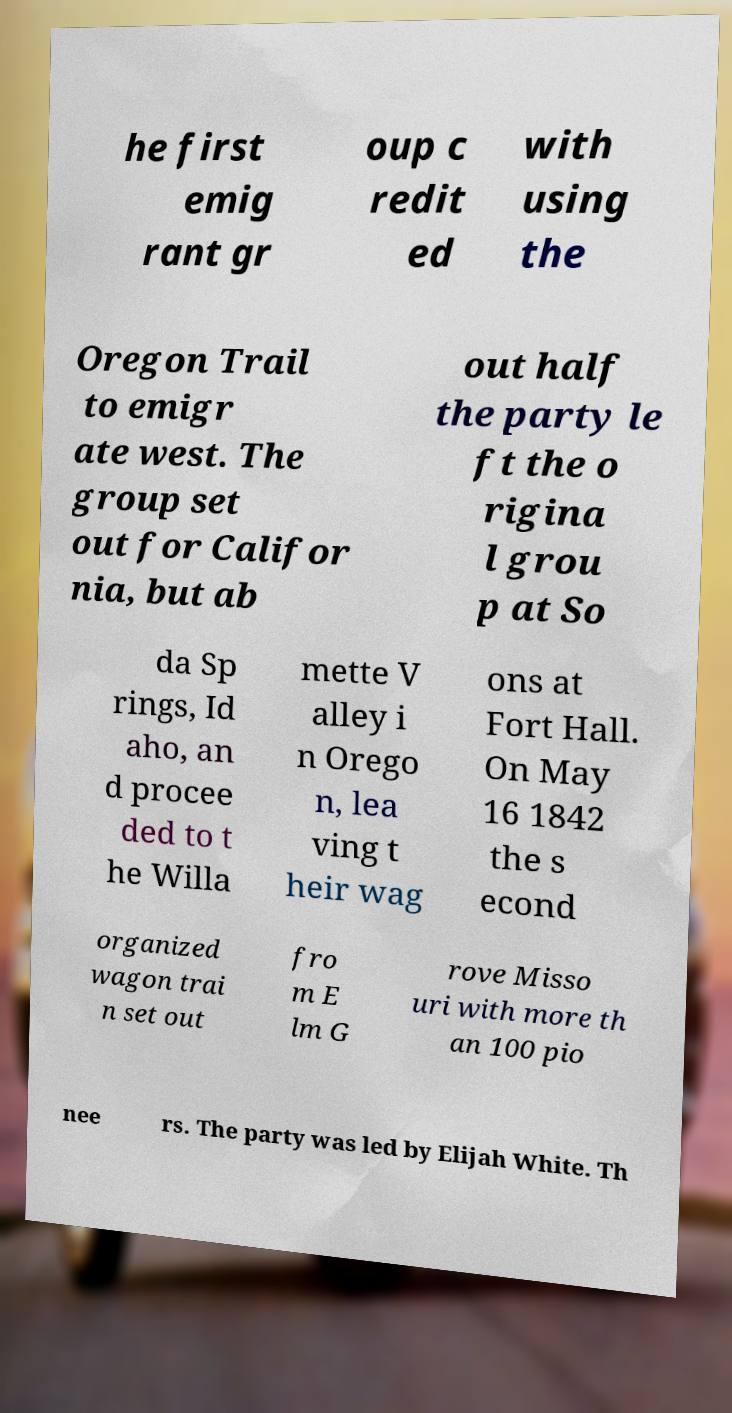There's text embedded in this image that I need extracted. Can you transcribe it verbatim? he first emig rant gr oup c redit ed with using the Oregon Trail to emigr ate west. The group set out for Califor nia, but ab out half the party le ft the o rigina l grou p at So da Sp rings, Id aho, an d procee ded to t he Willa mette V alley i n Orego n, lea ving t heir wag ons at Fort Hall. On May 16 1842 the s econd organized wagon trai n set out fro m E lm G rove Misso uri with more th an 100 pio nee rs. The party was led by Elijah White. Th 